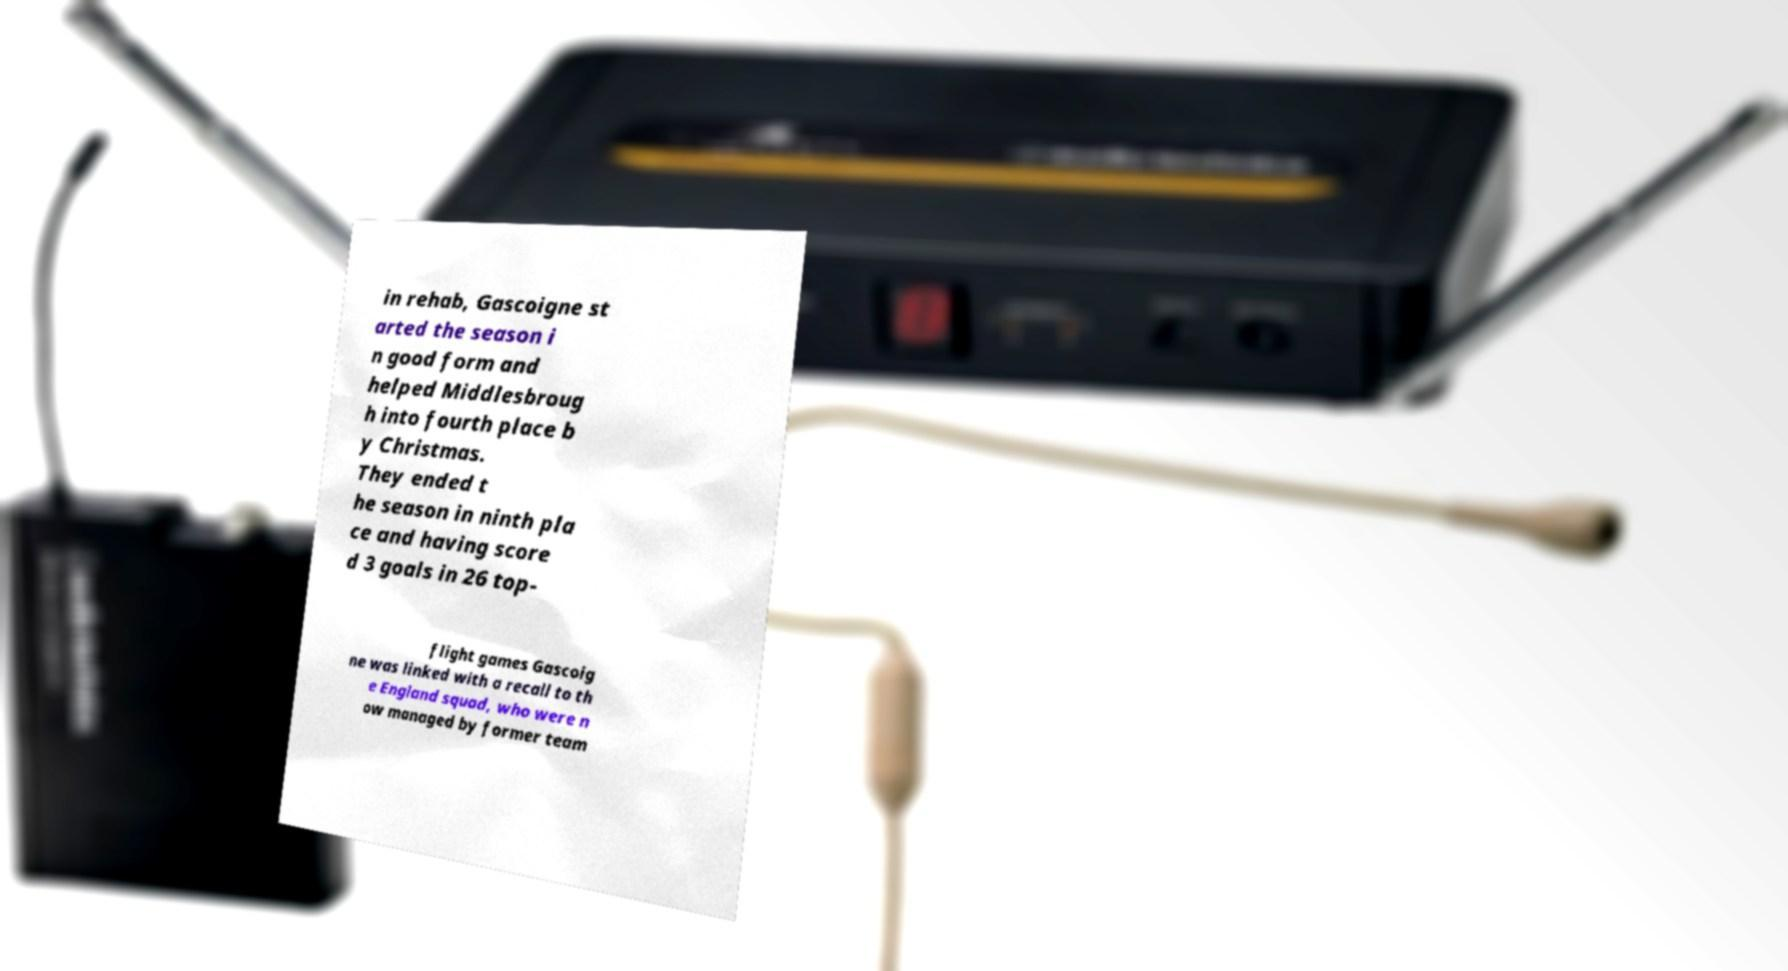Can you read and provide the text displayed in the image?This photo seems to have some interesting text. Can you extract and type it out for me? in rehab, Gascoigne st arted the season i n good form and helped Middlesbroug h into fourth place b y Christmas. They ended t he season in ninth pla ce and having score d 3 goals in 26 top- flight games Gascoig ne was linked with a recall to th e England squad, who were n ow managed by former team 